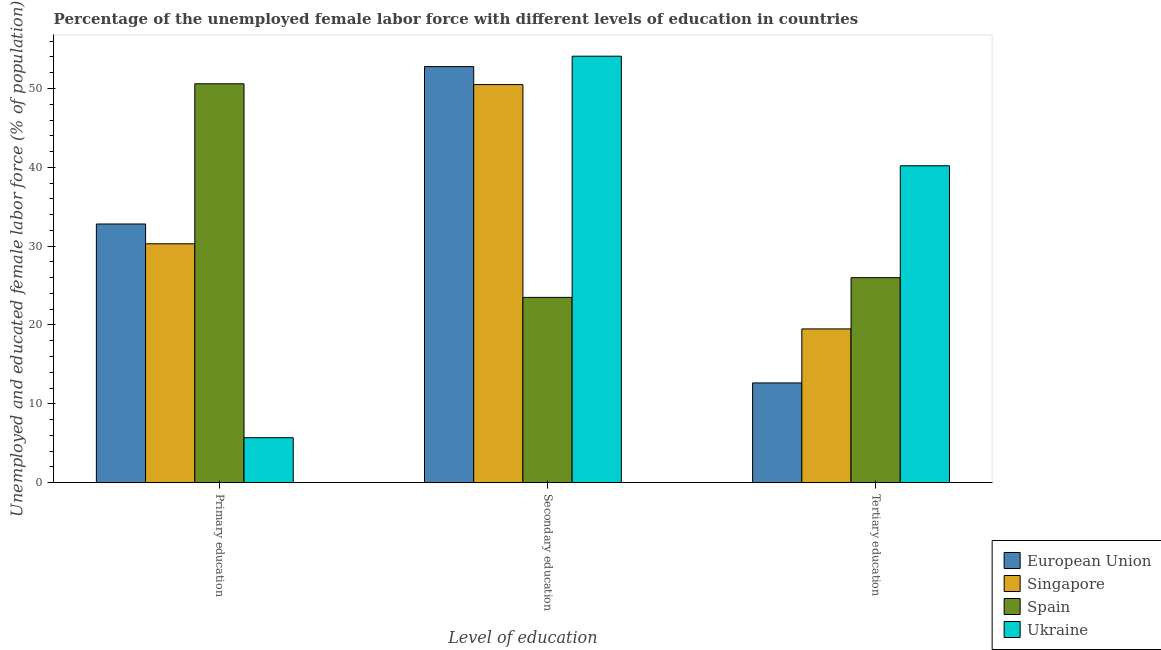Are the number of bars per tick equal to the number of legend labels?
Keep it short and to the point. Yes. Are the number of bars on each tick of the X-axis equal?
Your answer should be very brief. Yes. How many bars are there on the 1st tick from the right?
Give a very brief answer. 4. What is the label of the 1st group of bars from the left?
Your answer should be compact. Primary education. What is the percentage of female labor force who received secondary education in Spain?
Make the answer very short. 23.5. Across all countries, what is the maximum percentage of female labor force who received primary education?
Offer a very short reply. 50.6. Across all countries, what is the minimum percentage of female labor force who received secondary education?
Give a very brief answer. 23.5. In which country was the percentage of female labor force who received tertiary education maximum?
Keep it short and to the point. Ukraine. In which country was the percentage of female labor force who received tertiary education minimum?
Your answer should be very brief. European Union. What is the total percentage of female labor force who received tertiary education in the graph?
Make the answer very short. 98.35. What is the difference between the percentage of female labor force who received primary education in European Union and that in Spain?
Offer a very short reply. -17.79. What is the difference between the percentage of female labor force who received primary education in Spain and the percentage of female labor force who received secondary education in European Union?
Your answer should be compact. -2.18. What is the average percentage of female labor force who received secondary education per country?
Your answer should be compact. 45.22. What is the difference between the percentage of female labor force who received tertiary education and percentage of female labor force who received secondary education in Ukraine?
Your response must be concise. -13.9. In how many countries, is the percentage of female labor force who received tertiary education greater than 6 %?
Ensure brevity in your answer.  4. What is the ratio of the percentage of female labor force who received secondary education in European Union to that in Ukraine?
Ensure brevity in your answer.  0.98. Is the percentage of female labor force who received primary education in European Union less than that in Spain?
Keep it short and to the point. Yes. Is the difference between the percentage of female labor force who received tertiary education in Singapore and European Union greater than the difference between the percentage of female labor force who received secondary education in Singapore and European Union?
Ensure brevity in your answer.  Yes. What is the difference between the highest and the second highest percentage of female labor force who received tertiary education?
Ensure brevity in your answer.  14.2. What is the difference between the highest and the lowest percentage of female labor force who received secondary education?
Your answer should be very brief. 30.6. In how many countries, is the percentage of female labor force who received tertiary education greater than the average percentage of female labor force who received tertiary education taken over all countries?
Keep it short and to the point. 2. Is the sum of the percentage of female labor force who received primary education in Spain and Ukraine greater than the maximum percentage of female labor force who received secondary education across all countries?
Offer a terse response. Yes. What does the 2nd bar from the left in Primary education represents?
Make the answer very short. Singapore. What does the 3rd bar from the right in Secondary education represents?
Provide a succinct answer. Singapore. How many countries are there in the graph?
Give a very brief answer. 4. Where does the legend appear in the graph?
Keep it short and to the point. Bottom right. How are the legend labels stacked?
Offer a very short reply. Vertical. What is the title of the graph?
Your answer should be very brief. Percentage of the unemployed female labor force with different levels of education in countries. Does "St. Lucia" appear as one of the legend labels in the graph?
Offer a terse response. No. What is the label or title of the X-axis?
Ensure brevity in your answer.  Level of education. What is the label or title of the Y-axis?
Give a very brief answer. Unemployed and educated female labor force (% of population). What is the Unemployed and educated female labor force (% of population) of European Union in Primary education?
Offer a terse response. 32.81. What is the Unemployed and educated female labor force (% of population) in Singapore in Primary education?
Keep it short and to the point. 30.3. What is the Unemployed and educated female labor force (% of population) of Spain in Primary education?
Your answer should be compact. 50.6. What is the Unemployed and educated female labor force (% of population) in Ukraine in Primary education?
Your answer should be very brief. 5.7. What is the Unemployed and educated female labor force (% of population) in European Union in Secondary education?
Offer a very short reply. 52.78. What is the Unemployed and educated female labor force (% of population) in Singapore in Secondary education?
Offer a terse response. 50.5. What is the Unemployed and educated female labor force (% of population) of Ukraine in Secondary education?
Keep it short and to the point. 54.1. What is the Unemployed and educated female labor force (% of population) in European Union in Tertiary education?
Provide a short and direct response. 12.65. What is the Unemployed and educated female labor force (% of population) in Ukraine in Tertiary education?
Provide a succinct answer. 40.2. Across all Level of education, what is the maximum Unemployed and educated female labor force (% of population) in European Union?
Ensure brevity in your answer.  52.78. Across all Level of education, what is the maximum Unemployed and educated female labor force (% of population) of Singapore?
Your response must be concise. 50.5. Across all Level of education, what is the maximum Unemployed and educated female labor force (% of population) of Spain?
Your answer should be compact. 50.6. Across all Level of education, what is the maximum Unemployed and educated female labor force (% of population) in Ukraine?
Ensure brevity in your answer.  54.1. Across all Level of education, what is the minimum Unemployed and educated female labor force (% of population) of European Union?
Your answer should be compact. 12.65. Across all Level of education, what is the minimum Unemployed and educated female labor force (% of population) in Singapore?
Keep it short and to the point. 19.5. Across all Level of education, what is the minimum Unemployed and educated female labor force (% of population) of Spain?
Keep it short and to the point. 23.5. Across all Level of education, what is the minimum Unemployed and educated female labor force (% of population) of Ukraine?
Offer a very short reply. 5.7. What is the total Unemployed and educated female labor force (% of population) of European Union in the graph?
Your response must be concise. 98.24. What is the total Unemployed and educated female labor force (% of population) of Singapore in the graph?
Ensure brevity in your answer.  100.3. What is the total Unemployed and educated female labor force (% of population) in Spain in the graph?
Give a very brief answer. 100.1. What is the difference between the Unemployed and educated female labor force (% of population) in European Union in Primary education and that in Secondary education?
Keep it short and to the point. -19.97. What is the difference between the Unemployed and educated female labor force (% of population) in Singapore in Primary education and that in Secondary education?
Your answer should be compact. -20.2. What is the difference between the Unemployed and educated female labor force (% of population) in Spain in Primary education and that in Secondary education?
Keep it short and to the point. 27.1. What is the difference between the Unemployed and educated female labor force (% of population) in Ukraine in Primary education and that in Secondary education?
Make the answer very short. -48.4. What is the difference between the Unemployed and educated female labor force (% of population) in European Union in Primary education and that in Tertiary education?
Ensure brevity in your answer.  20.16. What is the difference between the Unemployed and educated female labor force (% of population) in Singapore in Primary education and that in Tertiary education?
Ensure brevity in your answer.  10.8. What is the difference between the Unemployed and educated female labor force (% of population) in Spain in Primary education and that in Tertiary education?
Provide a short and direct response. 24.6. What is the difference between the Unemployed and educated female labor force (% of population) in Ukraine in Primary education and that in Tertiary education?
Keep it short and to the point. -34.5. What is the difference between the Unemployed and educated female labor force (% of population) in European Union in Secondary education and that in Tertiary education?
Ensure brevity in your answer.  40.13. What is the difference between the Unemployed and educated female labor force (% of population) of Spain in Secondary education and that in Tertiary education?
Give a very brief answer. -2.5. What is the difference between the Unemployed and educated female labor force (% of population) of European Union in Primary education and the Unemployed and educated female labor force (% of population) of Singapore in Secondary education?
Your answer should be very brief. -17.69. What is the difference between the Unemployed and educated female labor force (% of population) in European Union in Primary education and the Unemployed and educated female labor force (% of population) in Spain in Secondary education?
Your answer should be compact. 9.31. What is the difference between the Unemployed and educated female labor force (% of population) of European Union in Primary education and the Unemployed and educated female labor force (% of population) of Ukraine in Secondary education?
Your response must be concise. -21.29. What is the difference between the Unemployed and educated female labor force (% of population) of Singapore in Primary education and the Unemployed and educated female labor force (% of population) of Spain in Secondary education?
Offer a terse response. 6.8. What is the difference between the Unemployed and educated female labor force (% of population) in Singapore in Primary education and the Unemployed and educated female labor force (% of population) in Ukraine in Secondary education?
Your response must be concise. -23.8. What is the difference between the Unemployed and educated female labor force (% of population) in European Union in Primary education and the Unemployed and educated female labor force (% of population) in Singapore in Tertiary education?
Give a very brief answer. 13.31. What is the difference between the Unemployed and educated female labor force (% of population) in European Union in Primary education and the Unemployed and educated female labor force (% of population) in Spain in Tertiary education?
Ensure brevity in your answer.  6.81. What is the difference between the Unemployed and educated female labor force (% of population) of European Union in Primary education and the Unemployed and educated female labor force (% of population) of Ukraine in Tertiary education?
Provide a succinct answer. -7.39. What is the difference between the Unemployed and educated female labor force (% of population) of Singapore in Primary education and the Unemployed and educated female labor force (% of population) of Spain in Tertiary education?
Keep it short and to the point. 4.3. What is the difference between the Unemployed and educated female labor force (% of population) of Singapore in Primary education and the Unemployed and educated female labor force (% of population) of Ukraine in Tertiary education?
Provide a succinct answer. -9.9. What is the difference between the Unemployed and educated female labor force (% of population) of Spain in Primary education and the Unemployed and educated female labor force (% of population) of Ukraine in Tertiary education?
Offer a very short reply. 10.4. What is the difference between the Unemployed and educated female labor force (% of population) in European Union in Secondary education and the Unemployed and educated female labor force (% of population) in Singapore in Tertiary education?
Give a very brief answer. 33.28. What is the difference between the Unemployed and educated female labor force (% of population) in European Union in Secondary education and the Unemployed and educated female labor force (% of population) in Spain in Tertiary education?
Keep it short and to the point. 26.78. What is the difference between the Unemployed and educated female labor force (% of population) in European Union in Secondary education and the Unemployed and educated female labor force (% of population) in Ukraine in Tertiary education?
Your response must be concise. 12.58. What is the difference between the Unemployed and educated female labor force (% of population) in Singapore in Secondary education and the Unemployed and educated female labor force (% of population) in Ukraine in Tertiary education?
Your response must be concise. 10.3. What is the difference between the Unemployed and educated female labor force (% of population) in Spain in Secondary education and the Unemployed and educated female labor force (% of population) in Ukraine in Tertiary education?
Give a very brief answer. -16.7. What is the average Unemployed and educated female labor force (% of population) of European Union per Level of education?
Make the answer very short. 32.75. What is the average Unemployed and educated female labor force (% of population) in Singapore per Level of education?
Keep it short and to the point. 33.43. What is the average Unemployed and educated female labor force (% of population) of Spain per Level of education?
Make the answer very short. 33.37. What is the average Unemployed and educated female labor force (% of population) in Ukraine per Level of education?
Provide a short and direct response. 33.33. What is the difference between the Unemployed and educated female labor force (% of population) of European Union and Unemployed and educated female labor force (% of population) of Singapore in Primary education?
Offer a very short reply. 2.51. What is the difference between the Unemployed and educated female labor force (% of population) of European Union and Unemployed and educated female labor force (% of population) of Spain in Primary education?
Ensure brevity in your answer.  -17.79. What is the difference between the Unemployed and educated female labor force (% of population) in European Union and Unemployed and educated female labor force (% of population) in Ukraine in Primary education?
Provide a succinct answer. 27.11. What is the difference between the Unemployed and educated female labor force (% of population) in Singapore and Unemployed and educated female labor force (% of population) in Spain in Primary education?
Provide a succinct answer. -20.3. What is the difference between the Unemployed and educated female labor force (% of population) in Singapore and Unemployed and educated female labor force (% of population) in Ukraine in Primary education?
Offer a very short reply. 24.6. What is the difference between the Unemployed and educated female labor force (% of population) in Spain and Unemployed and educated female labor force (% of population) in Ukraine in Primary education?
Offer a terse response. 44.9. What is the difference between the Unemployed and educated female labor force (% of population) in European Union and Unemployed and educated female labor force (% of population) in Singapore in Secondary education?
Provide a short and direct response. 2.28. What is the difference between the Unemployed and educated female labor force (% of population) of European Union and Unemployed and educated female labor force (% of population) of Spain in Secondary education?
Provide a succinct answer. 29.28. What is the difference between the Unemployed and educated female labor force (% of population) in European Union and Unemployed and educated female labor force (% of population) in Ukraine in Secondary education?
Your response must be concise. -1.32. What is the difference between the Unemployed and educated female labor force (% of population) of Singapore and Unemployed and educated female labor force (% of population) of Spain in Secondary education?
Make the answer very short. 27. What is the difference between the Unemployed and educated female labor force (% of population) in Spain and Unemployed and educated female labor force (% of population) in Ukraine in Secondary education?
Your answer should be very brief. -30.6. What is the difference between the Unemployed and educated female labor force (% of population) of European Union and Unemployed and educated female labor force (% of population) of Singapore in Tertiary education?
Your answer should be compact. -6.85. What is the difference between the Unemployed and educated female labor force (% of population) in European Union and Unemployed and educated female labor force (% of population) in Spain in Tertiary education?
Offer a very short reply. -13.35. What is the difference between the Unemployed and educated female labor force (% of population) of European Union and Unemployed and educated female labor force (% of population) of Ukraine in Tertiary education?
Give a very brief answer. -27.55. What is the difference between the Unemployed and educated female labor force (% of population) of Singapore and Unemployed and educated female labor force (% of population) of Spain in Tertiary education?
Your answer should be compact. -6.5. What is the difference between the Unemployed and educated female labor force (% of population) of Singapore and Unemployed and educated female labor force (% of population) of Ukraine in Tertiary education?
Keep it short and to the point. -20.7. What is the ratio of the Unemployed and educated female labor force (% of population) in European Union in Primary education to that in Secondary education?
Your response must be concise. 0.62. What is the ratio of the Unemployed and educated female labor force (% of population) of Singapore in Primary education to that in Secondary education?
Your answer should be very brief. 0.6. What is the ratio of the Unemployed and educated female labor force (% of population) in Spain in Primary education to that in Secondary education?
Keep it short and to the point. 2.15. What is the ratio of the Unemployed and educated female labor force (% of population) in Ukraine in Primary education to that in Secondary education?
Offer a terse response. 0.11. What is the ratio of the Unemployed and educated female labor force (% of population) of European Union in Primary education to that in Tertiary education?
Give a very brief answer. 2.59. What is the ratio of the Unemployed and educated female labor force (% of population) in Singapore in Primary education to that in Tertiary education?
Your answer should be compact. 1.55. What is the ratio of the Unemployed and educated female labor force (% of population) of Spain in Primary education to that in Tertiary education?
Ensure brevity in your answer.  1.95. What is the ratio of the Unemployed and educated female labor force (% of population) of Ukraine in Primary education to that in Tertiary education?
Your answer should be compact. 0.14. What is the ratio of the Unemployed and educated female labor force (% of population) in European Union in Secondary education to that in Tertiary education?
Provide a succinct answer. 4.17. What is the ratio of the Unemployed and educated female labor force (% of population) in Singapore in Secondary education to that in Tertiary education?
Provide a succinct answer. 2.59. What is the ratio of the Unemployed and educated female labor force (% of population) in Spain in Secondary education to that in Tertiary education?
Provide a short and direct response. 0.9. What is the ratio of the Unemployed and educated female labor force (% of population) in Ukraine in Secondary education to that in Tertiary education?
Provide a short and direct response. 1.35. What is the difference between the highest and the second highest Unemployed and educated female labor force (% of population) of European Union?
Your answer should be compact. 19.97. What is the difference between the highest and the second highest Unemployed and educated female labor force (% of population) of Singapore?
Offer a very short reply. 20.2. What is the difference between the highest and the second highest Unemployed and educated female labor force (% of population) of Spain?
Offer a terse response. 24.6. What is the difference between the highest and the second highest Unemployed and educated female labor force (% of population) of Ukraine?
Your response must be concise. 13.9. What is the difference between the highest and the lowest Unemployed and educated female labor force (% of population) in European Union?
Offer a very short reply. 40.13. What is the difference between the highest and the lowest Unemployed and educated female labor force (% of population) in Singapore?
Your response must be concise. 31. What is the difference between the highest and the lowest Unemployed and educated female labor force (% of population) of Spain?
Your response must be concise. 27.1. What is the difference between the highest and the lowest Unemployed and educated female labor force (% of population) of Ukraine?
Your answer should be very brief. 48.4. 